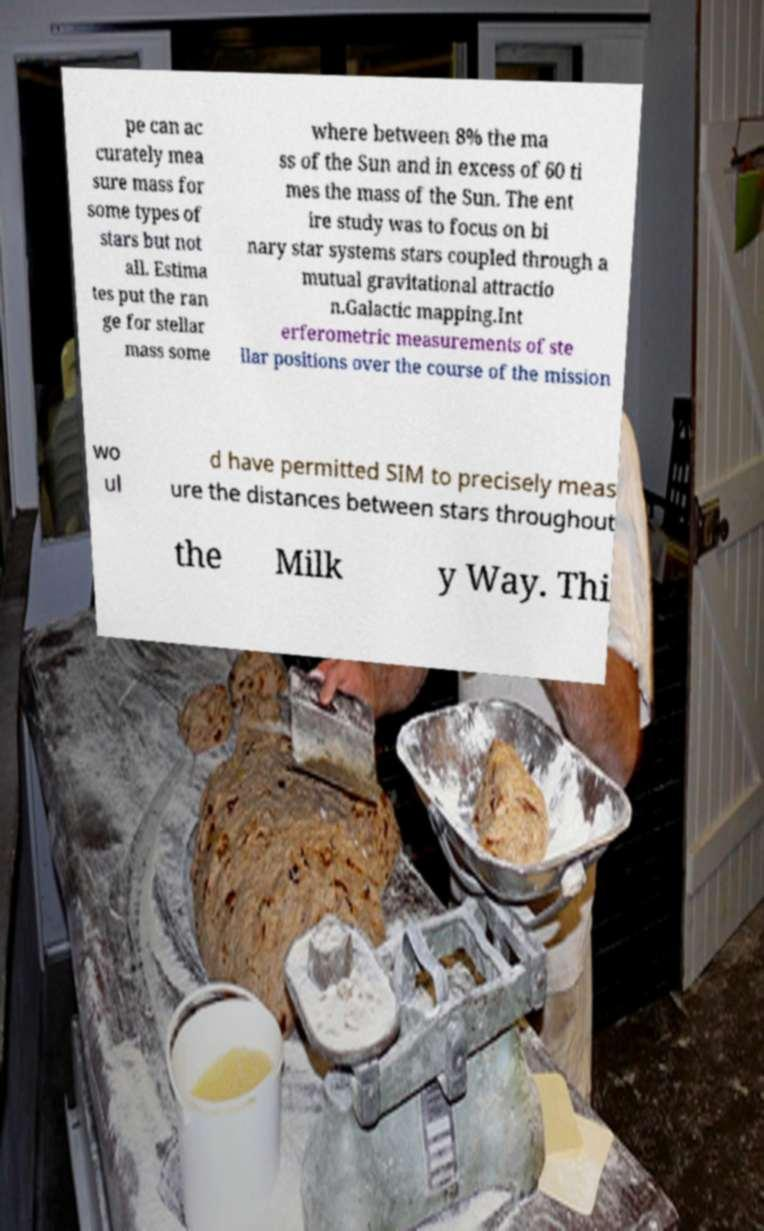Could you assist in decoding the text presented in this image and type it out clearly? pe can ac curately mea sure mass for some types of stars but not all. Estima tes put the ran ge for stellar mass some where between 8% the ma ss of the Sun and in excess of 60 ti mes the mass of the Sun. The ent ire study was to focus on bi nary star systems stars coupled through a mutual gravitational attractio n.Galactic mapping.Int erferometric measurements of ste llar positions over the course of the mission wo ul d have permitted SIM to precisely meas ure the distances between stars throughout the Milk y Way. Thi 